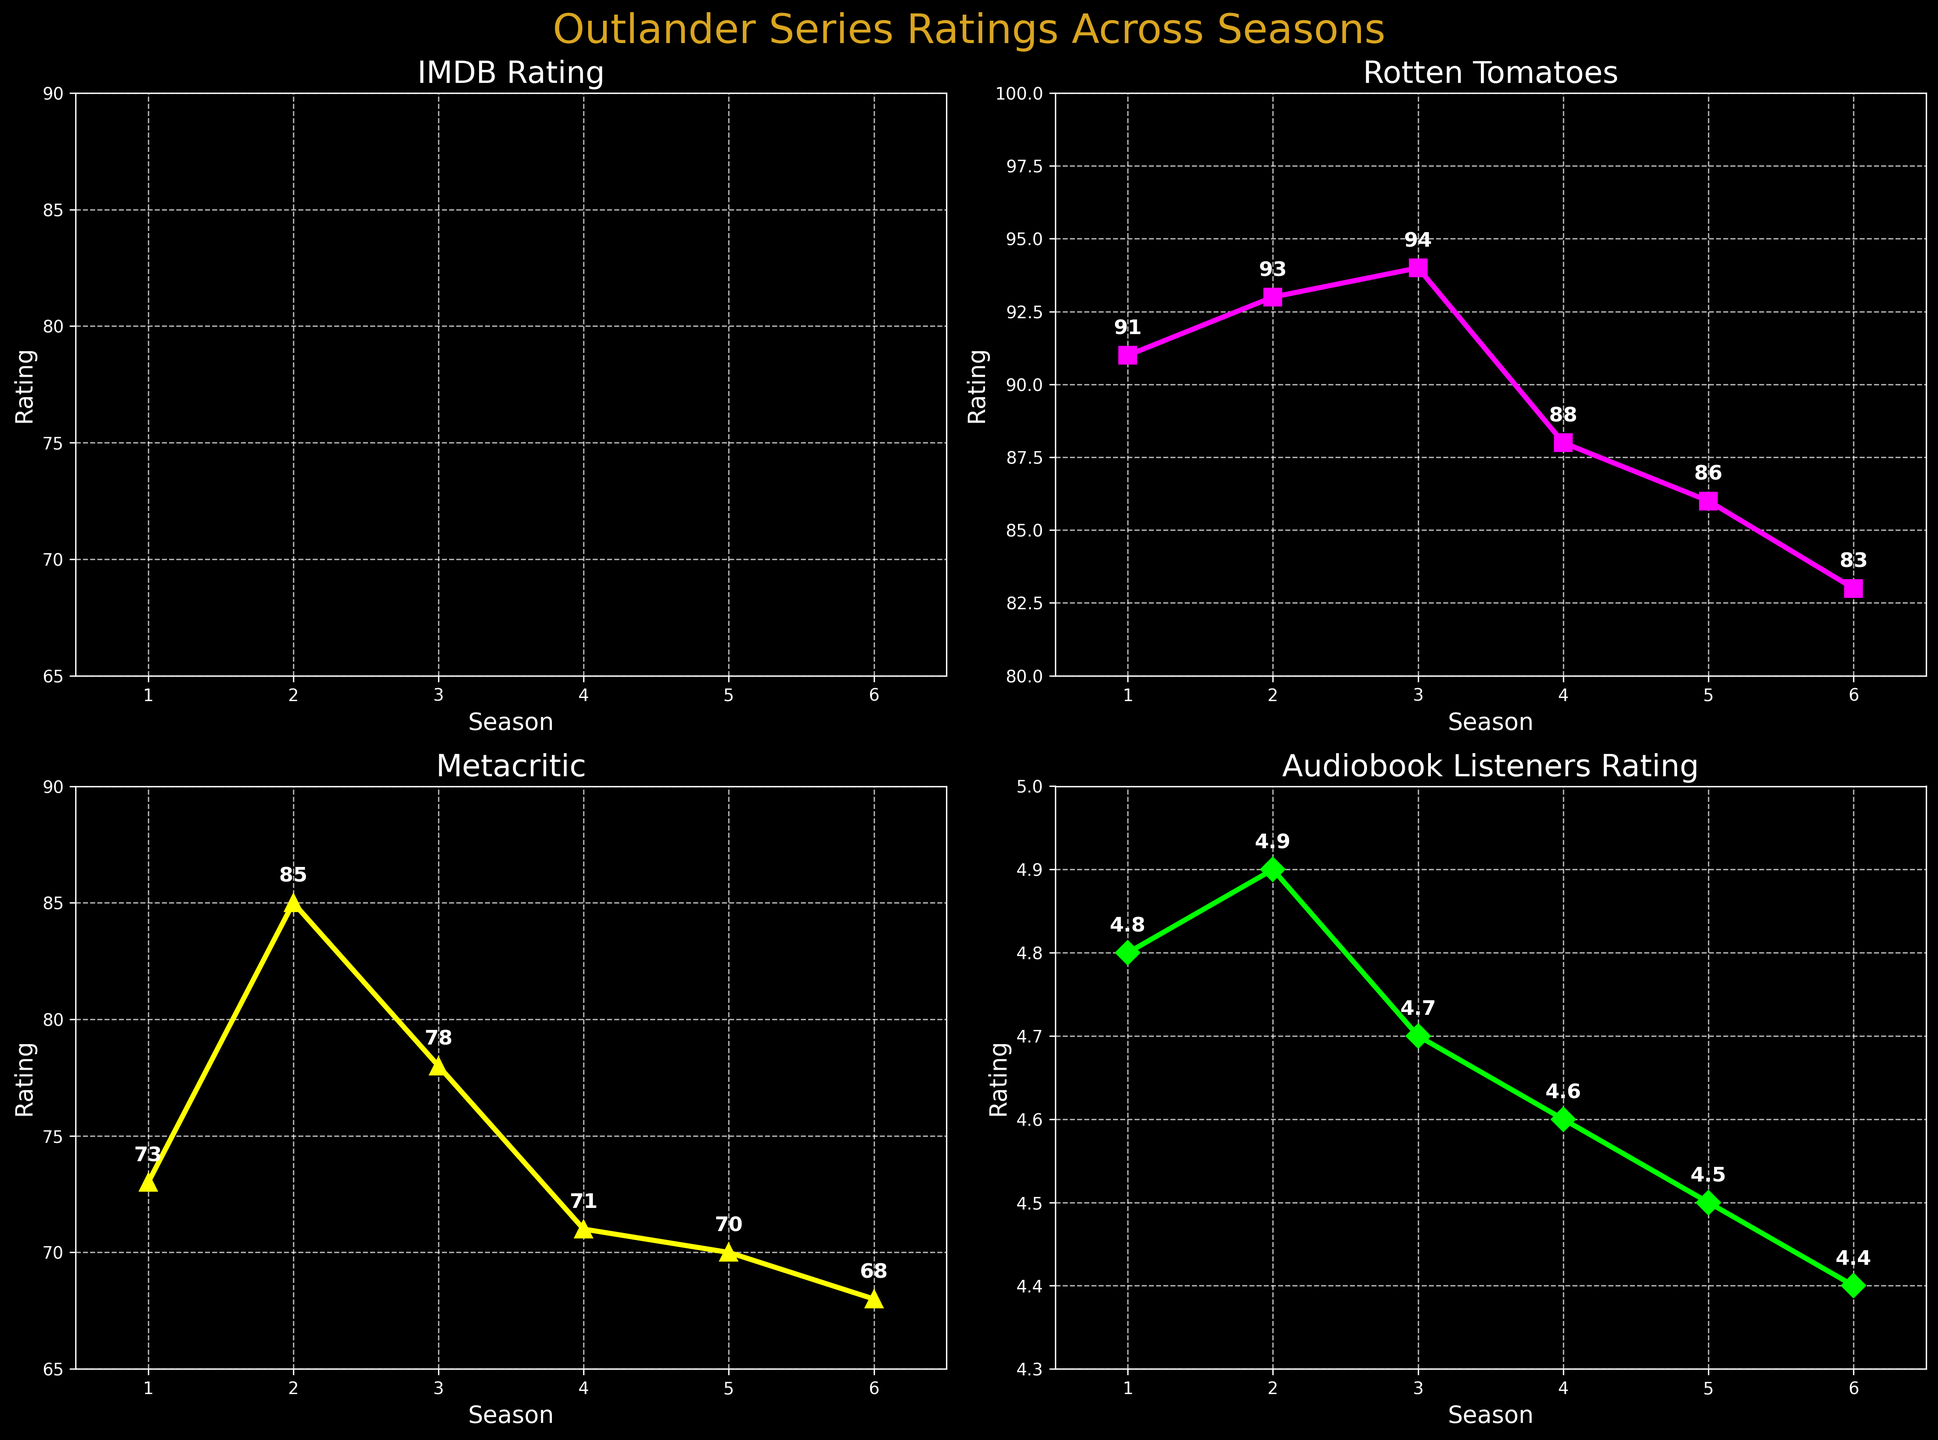what is the title of the figure? The title is written at the top of the figure. It reads "Outlander Series Ratings Across Seasons."
Answer: Outlander Series Ratings Across Seasons How many data points are there for each subplot? Each subplot represents data for 6 seasons of the Outlander series. Thus, there are 6 data points in each subplot.
Answer: 6 Which rating source has the highest value in Season 2? By examining Season 2 across all subplots, the highest rating is found in "Rotten Tomatoes" with a value of 93.
Answer: Rotten Tomatoes What is the range of the Audiobook Listeners Rating? The Audiobook Listeners Rating ranges from the lowest value in Season 6 (4.4) to the highest value in Season 2 (4.9). Subtract the minimum from the maximum to get the range: 4.9 - 4.4 = 0.5.
Answer: 0.5 Which rating source shows a declining trend over the seasons? By inspecting the plot lines, the "Audiobook Listeners Rating" subplot shows a consistently declining trend from Season 1 (4.8) to Season 6 (4.4).
Answer: Audiobook Listeners Rating Comparing Season 5 and Season 6, which season has higher IMDB Rating? The IMDB Rating for Season 5 is 8.2 and for Season 6 is 7.9. Therefore, Season 5 has a higher IMDB Rating.
Answer: Season 5 What is the average IMDB Rating across all seasons? Add the IMDB Ratings for all seasons: 8.5 + 8.7 + 8.6 + 8.4 + 8.2 + 7.9 = 50.3. Then, divide by the number of seasons, which is 6. 50.3 / 6 = 8.38.
Answer: 8.38 Which subplot has the most variations in the y-axis limit? "Audiobook Listeners Rating" has the y-axis limits of 4.3 to 5.0, showing less variation compared to the other subplots which range around 65 to 100. Hence, it has the smallest range, indicating fewer variations on the y-axis.
Answer: Audiobook Listeners Rating How many unique colors are used in the subplots? Each subplot has a unique color: cyan, magenta, yellow, and lime. So there are 4 unique colors.
Answer: 4 